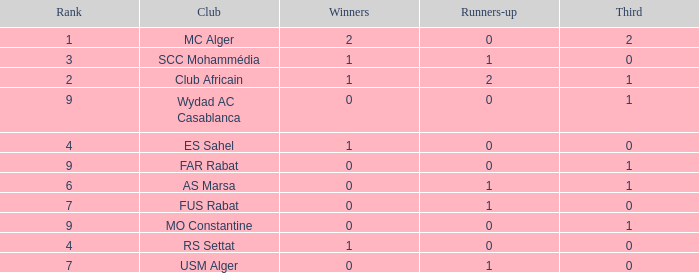Which Rank has a Third of 2, and Winners smaller than 2? None. 